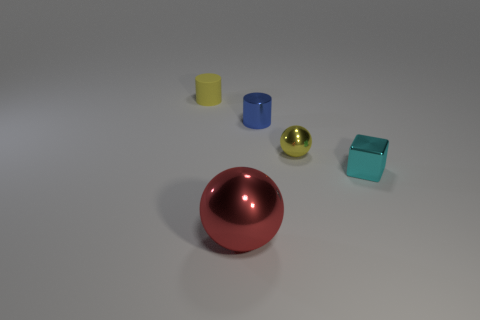Subtract all yellow cylinders. How many cylinders are left? 1 Add 2 tiny yellow things. How many objects exist? 7 Subtract all cubes. How many objects are left? 4 Subtract 1 cylinders. How many cylinders are left? 1 Add 1 tiny blue matte things. How many tiny blue matte things exist? 1 Subtract 0 cyan spheres. How many objects are left? 5 Subtract all purple cylinders. Subtract all green cubes. How many cylinders are left? 2 Subtract all blue cylinders. How many green cubes are left? 0 Subtract all small yellow metal cubes. Subtract all yellow cylinders. How many objects are left? 4 Add 5 tiny yellow cylinders. How many tiny yellow cylinders are left? 6 